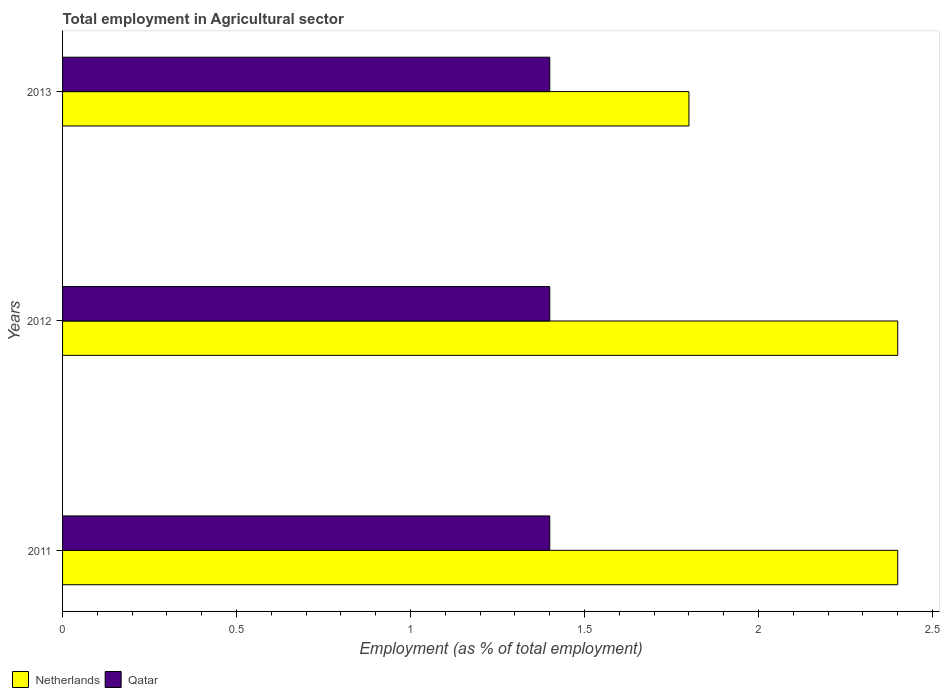How many different coloured bars are there?
Provide a succinct answer. 2. How many groups of bars are there?
Make the answer very short. 3. Are the number of bars per tick equal to the number of legend labels?
Your response must be concise. Yes. How many bars are there on the 1st tick from the bottom?
Your answer should be very brief. 2. In how many cases, is the number of bars for a given year not equal to the number of legend labels?
Keep it short and to the point. 0. What is the employment in agricultural sector in Netherlands in 2012?
Make the answer very short. 2.4. Across all years, what is the maximum employment in agricultural sector in Qatar?
Provide a succinct answer. 1.4. Across all years, what is the minimum employment in agricultural sector in Netherlands?
Ensure brevity in your answer.  1.8. In which year was the employment in agricultural sector in Netherlands minimum?
Keep it short and to the point. 2013. What is the total employment in agricultural sector in Netherlands in the graph?
Keep it short and to the point. 6.6. What is the difference between the employment in agricultural sector in Netherlands in 2011 and that in 2013?
Ensure brevity in your answer.  0.6. What is the difference between the employment in agricultural sector in Qatar in 2011 and the employment in agricultural sector in Netherlands in 2012?
Provide a succinct answer. -1. What is the average employment in agricultural sector in Qatar per year?
Make the answer very short. 1.4. In the year 2013, what is the difference between the employment in agricultural sector in Qatar and employment in agricultural sector in Netherlands?
Ensure brevity in your answer.  -0.4. In how many years, is the employment in agricultural sector in Qatar greater than 2.1 %?
Ensure brevity in your answer.  0. What is the ratio of the employment in agricultural sector in Qatar in 2012 to that in 2013?
Provide a succinct answer. 1. Is the difference between the employment in agricultural sector in Qatar in 2012 and 2013 greater than the difference between the employment in agricultural sector in Netherlands in 2012 and 2013?
Provide a succinct answer. No. What is the difference between the highest and the lowest employment in agricultural sector in Qatar?
Keep it short and to the point. 0. Is the sum of the employment in agricultural sector in Qatar in 2011 and 2012 greater than the maximum employment in agricultural sector in Netherlands across all years?
Give a very brief answer. Yes. What does the 1st bar from the top in 2013 represents?
Provide a short and direct response. Qatar. What does the 2nd bar from the bottom in 2012 represents?
Your response must be concise. Qatar. How many bars are there?
Your response must be concise. 6. What is the difference between two consecutive major ticks on the X-axis?
Give a very brief answer. 0.5. Are the values on the major ticks of X-axis written in scientific E-notation?
Offer a terse response. No. Does the graph contain grids?
Keep it short and to the point. No. Where does the legend appear in the graph?
Provide a short and direct response. Bottom left. How are the legend labels stacked?
Make the answer very short. Horizontal. What is the title of the graph?
Give a very brief answer. Total employment in Agricultural sector. Does "Solomon Islands" appear as one of the legend labels in the graph?
Offer a terse response. No. What is the label or title of the X-axis?
Your answer should be compact. Employment (as % of total employment). What is the label or title of the Y-axis?
Keep it short and to the point. Years. What is the Employment (as % of total employment) in Netherlands in 2011?
Give a very brief answer. 2.4. What is the Employment (as % of total employment) of Qatar in 2011?
Your response must be concise. 1.4. What is the Employment (as % of total employment) of Netherlands in 2012?
Your answer should be compact. 2.4. What is the Employment (as % of total employment) of Qatar in 2012?
Your answer should be very brief. 1.4. What is the Employment (as % of total employment) of Netherlands in 2013?
Give a very brief answer. 1.8. What is the Employment (as % of total employment) in Qatar in 2013?
Your response must be concise. 1.4. Across all years, what is the maximum Employment (as % of total employment) in Netherlands?
Provide a succinct answer. 2.4. Across all years, what is the maximum Employment (as % of total employment) of Qatar?
Offer a very short reply. 1.4. Across all years, what is the minimum Employment (as % of total employment) of Netherlands?
Give a very brief answer. 1.8. Across all years, what is the minimum Employment (as % of total employment) of Qatar?
Provide a short and direct response. 1.4. What is the difference between the Employment (as % of total employment) in Netherlands in 2011 and that in 2012?
Your response must be concise. 0. What is the difference between the Employment (as % of total employment) in Netherlands in 2011 and that in 2013?
Provide a succinct answer. 0.6. What is the difference between the Employment (as % of total employment) in Netherlands in 2012 and that in 2013?
Your response must be concise. 0.6. What is the difference between the Employment (as % of total employment) in Netherlands in 2012 and the Employment (as % of total employment) in Qatar in 2013?
Offer a very short reply. 1. What is the average Employment (as % of total employment) in Netherlands per year?
Give a very brief answer. 2.2. In the year 2011, what is the difference between the Employment (as % of total employment) of Netherlands and Employment (as % of total employment) of Qatar?
Keep it short and to the point. 1. In the year 2013, what is the difference between the Employment (as % of total employment) in Netherlands and Employment (as % of total employment) in Qatar?
Keep it short and to the point. 0.4. What is the ratio of the Employment (as % of total employment) of Qatar in 2011 to that in 2012?
Keep it short and to the point. 1. What is the ratio of the Employment (as % of total employment) of Netherlands in 2011 to that in 2013?
Give a very brief answer. 1.33. What is the ratio of the Employment (as % of total employment) in Netherlands in 2012 to that in 2013?
Keep it short and to the point. 1.33. What is the difference between the highest and the second highest Employment (as % of total employment) in Qatar?
Ensure brevity in your answer.  0. What is the difference between the highest and the lowest Employment (as % of total employment) of Qatar?
Make the answer very short. 0. 